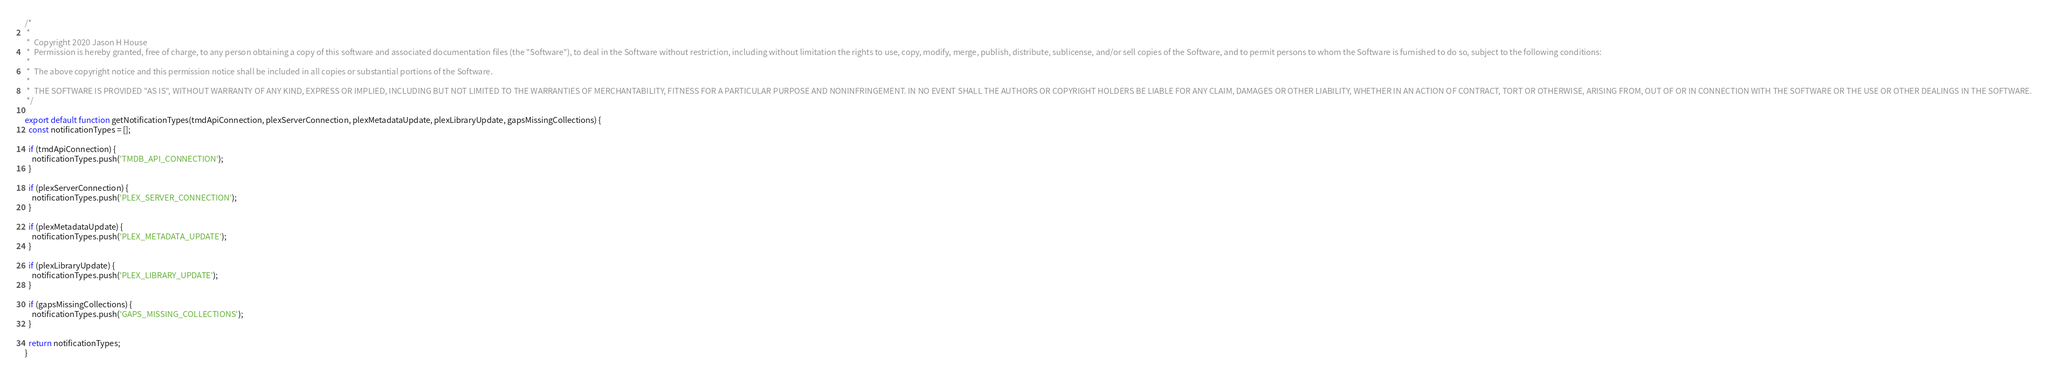<code> <loc_0><loc_0><loc_500><loc_500><_JavaScript_>/*
 *
 *  Copyright 2020 Jason H House
 *  Permission is hereby granted, free of charge, to any person obtaining a copy of this software and associated documentation files (the "Software"), to deal in the Software without restriction, including without limitation the rights to use, copy, modify, merge, publish, distribute, sublicense, and/or sell copies of the Software, and to permit persons to whom the Software is furnished to do so, subject to the following conditions:
 *
 *  The above copyright notice and this permission notice shall be included in all copies or substantial portions of the Software.
 *
 *  THE SOFTWARE IS PROVIDED "AS IS", WITHOUT WARRANTY OF ANY KIND, EXPRESS OR IMPLIED, INCLUDING BUT NOT LIMITED TO THE WARRANTIES OF MERCHANTABILITY, FITNESS FOR A PARTICULAR PURPOSE AND NONINFRINGEMENT. IN NO EVENT SHALL THE AUTHORS OR COPYRIGHT HOLDERS BE LIABLE FOR ANY CLAIM, DAMAGES OR OTHER LIABILITY, WHETHER IN AN ACTION OF CONTRACT, TORT OR OTHERWISE, ARISING FROM, OUT OF OR IN CONNECTION WITH THE SOFTWARE OR THE USE OR OTHER DEALINGS IN THE SOFTWARE.
 */

export default function getNotificationTypes(tmdApiConnection, plexServerConnection, plexMetadataUpdate, plexLibraryUpdate, gapsMissingCollections) {
  const notificationTypes = [];

  if (tmdApiConnection) {
    notificationTypes.push('TMDB_API_CONNECTION');
  }

  if (plexServerConnection) {
    notificationTypes.push('PLEX_SERVER_CONNECTION');
  }

  if (plexMetadataUpdate) {
    notificationTypes.push('PLEX_METADATA_UPDATE');
  }

  if (plexLibraryUpdate) {
    notificationTypes.push('PLEX_LIBRARY_UPDATE');
  }

  if (gapsMissingCollections) {
    notificationTypes.push('GAPS_MISSING_COLLECTIONS');
  }

  return notificationTypes;
}
</code> 